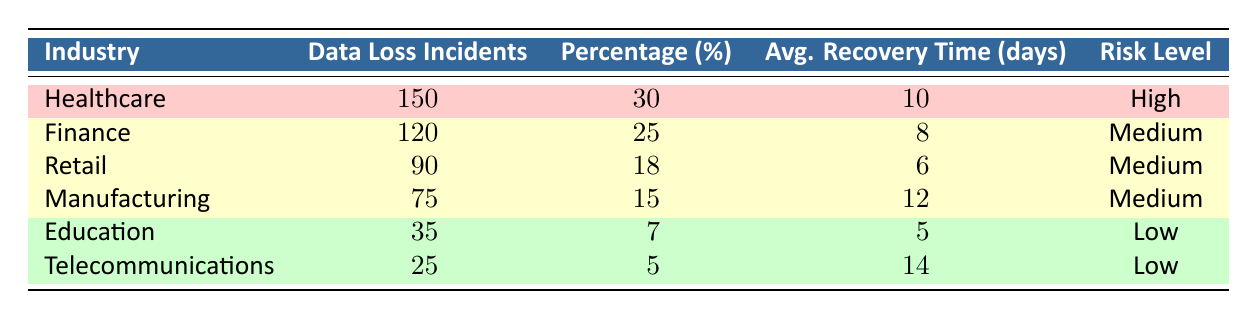What industry has the highest number of data loss incidents? Referring to the table, the industry with the highest number of data loss incidents is Healthcare, which has 150 incidents.
Answer: Healthcare What is the average recovery time for the Finance industry? The average recovery time for the Finance industry is indicated in the table as 8 days.
Answer: 8 days How many total data loss incidents are reported across all industries? To find the total, sum the data loss incidents: 150 + 120 + 90 + 75 + 35 + 25 = 495. Therefore, there are 495 total incidents.
Answer: 495 What percentage of total data loss incidents does the Telecommunications industry represent? The table states that the Telecommunications industry has 25 incidents, which is 5% of the total.
Answer: 5% Which industries have a medium risk level? According to the table, the industries with a medium risk level are Finance, Retail, and Manufacturing.
Answer: Finance, Retail, Manufacturing What is the difference in average recovery time between Healthcare and Education? Healthcare has an average recovery time of 10 days, while Education has 5 days. The difference is 10 - 5 = 5 days.
Answer: 5 days Is the average recovery time for the Retail industry less than the average recovery time for the Telecommunications industry? The Retail industry has an average recovery time of 6 days, while Telecommunications has 14 days. Since 6 is not less than 14, the statement is false.
Answer: No If you combine the data loss incidents of Manufacturing and Education, what is the total? The total incidents from Manufacturing (75) and Education (35) are combined as 75 + 35 = 110.
Answer: 110 Which industry has the lowest average recovery time? The table shows that Education has the lowest average recovery time of 5 days compared to all other industries.
Answer: Education What is the ratio of data loss incidents in the Healthcare industry to those in the Retail industry? The Healthcare industry has 150 incidents and Retail has 90. The ratio is 150:90, which simplifies to 5:3.
Answer: 5:3 